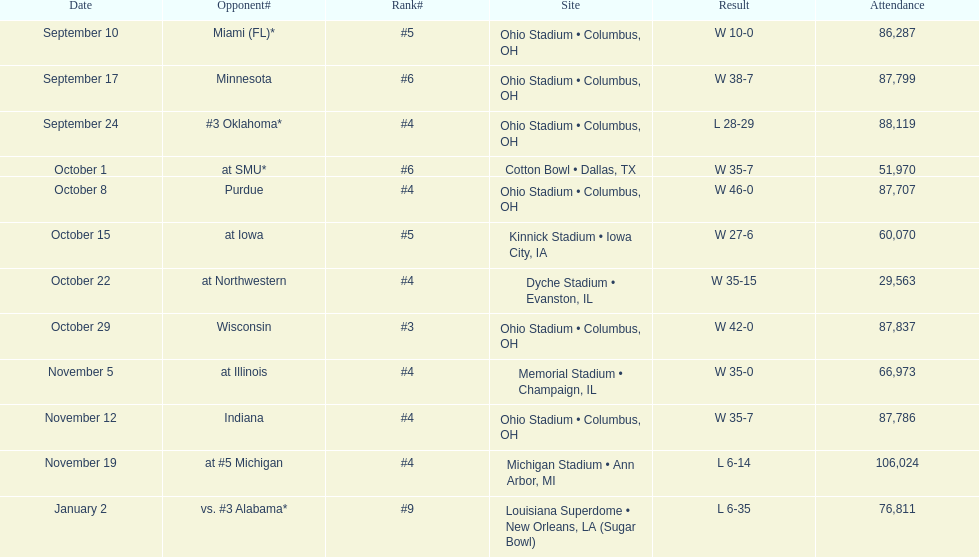How many games did this team win during this season? 9. 